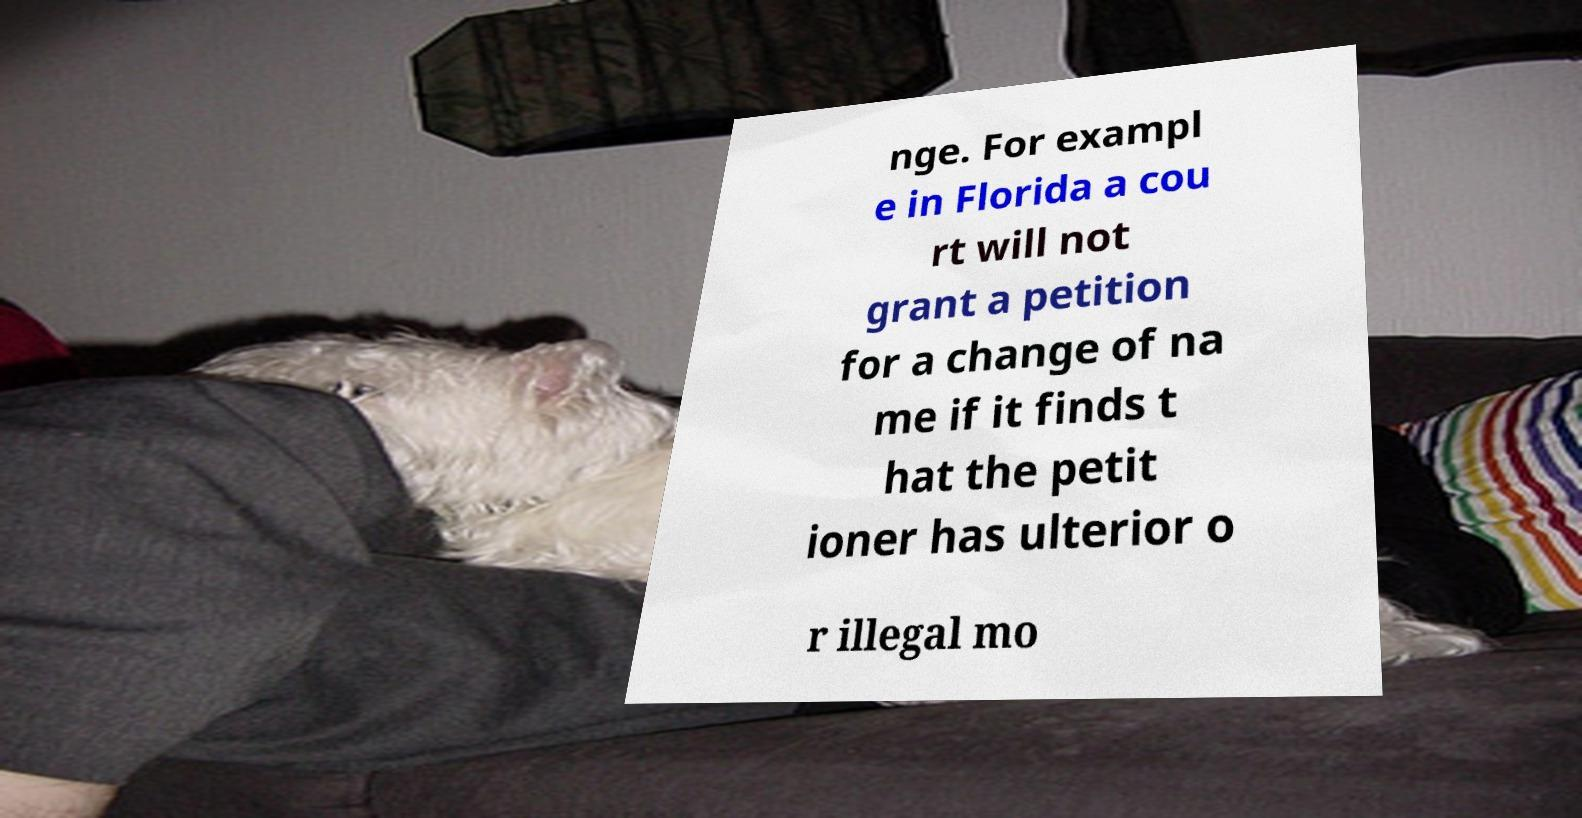For documentation purposes, I need the text within this image transcribed. Could you provide that? nge. For exampl e in Florida a cou rt will not grant a petition for a change of na me if it finds t hat the petit ioner has ulterior o r illegal mo 